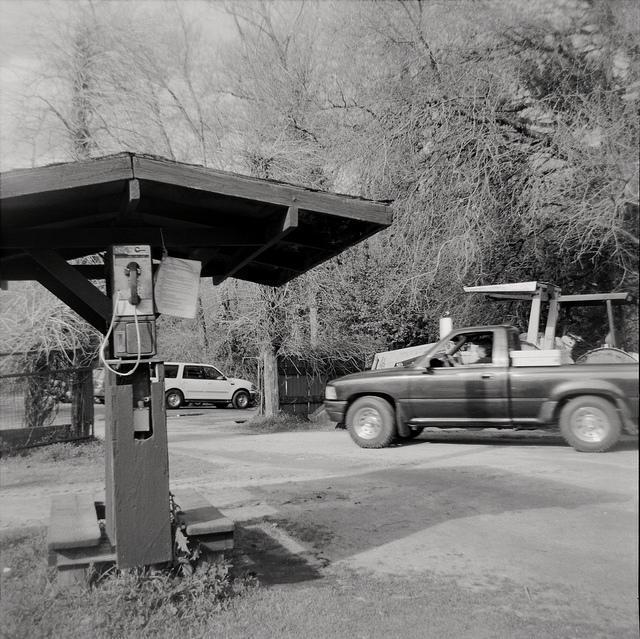How many trucks are visible?
Give a very brief answer. 2. How many benches are there?
Give a very brief answer. 2. How many tires are visible in between the two greyhound dog logos?
Give a very brief answer. 0. 